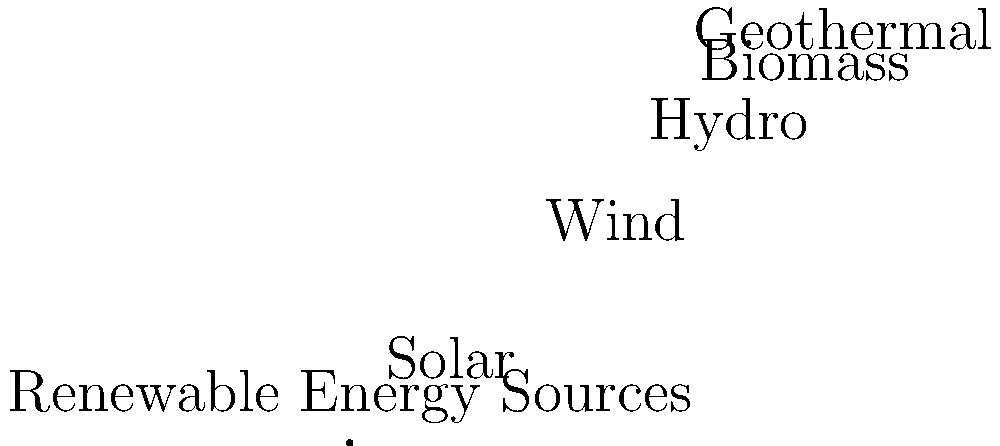Based on the pie chart showing the distribution of renewable energy sources in an urban area, which combination of energy sources contributes to 65% of the total renewable energy production? To solve this question, we need to analyze the pie chart and sum up the percentages of different renewable energy sources until we reach 65%. Let's go through this step-by-step:

1. First, let's list out the energy sources and their percentages:
   - Solar: 40%
   - Wind: 25%
   - Hydro: 20%
   - Biomass: 10%
   - Geothermal: 5%

2. We need to find a combination that adds up to 65%. Let's start with the largest percentage and work our way down:

3. Solar (40%) + Wind (25%) = 65%

4. This combination exactly matches our target of 65%.

5. We don't need to consider any other combinations, as we've found the exact match.

Therefore, the combination of Solar and Wind energy sources contributes to 65% of the total renewable energy production in this urban area.
Answer: Solar and Wind 